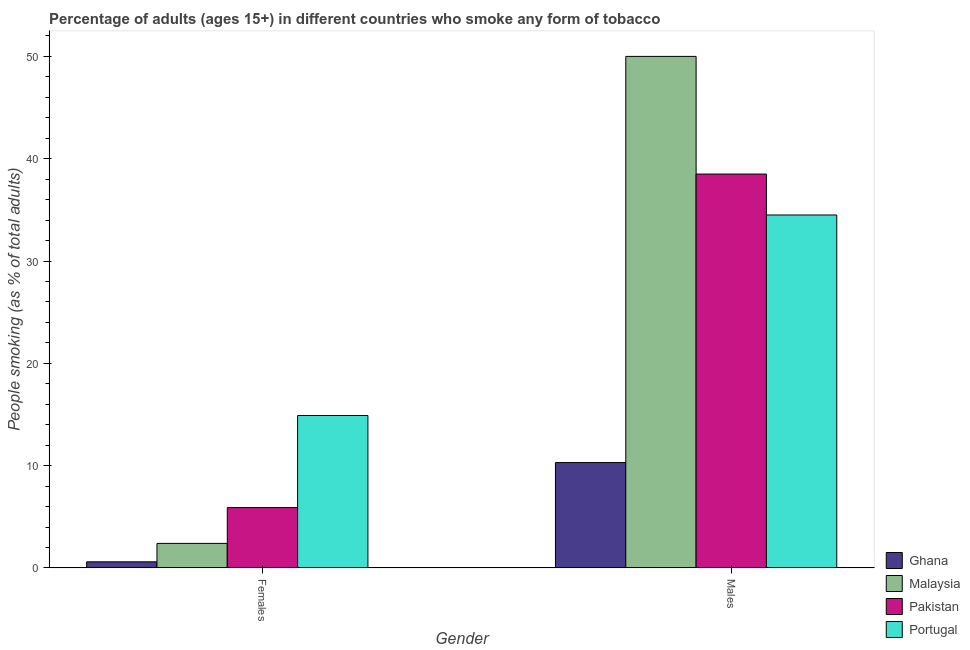Are the number of bars on each tick of the X-axis equal?
Offer a terse response. Yes. How many bars are there on the 2nd tick from the right?
Your response must be concise. 4. What is the label of the 1st group of bars from the left?
Ensure brevity in your answer.  Females. What is the percentage of males who smoke in Portugal?
Your answer should be very brief. 34.5. Across all countries, what is the maximum percentage of males who smoke?
Provide a succinct answer. 50. In which country was the percentage of females who smoke maximum?
Your response must be concise. Portugal. What is the total percentage of males who smoke in the graph?
Offer a terse response. 133.3. What is the difference between the percentage of females who smoke in Portugal and that in Ghana?
Your response must be concise. 14.3. What is the difference between the percentage of females who smoke in Portugal and the percentage of males who smoke in Pakistan?
Offer a very short reply. -23.6. What is the average percentage of males who smoke per country?
Your answer should be compact. 33.33. What is the difference between the percentage of males who smoke and percentage of females who smoke in Portugal?
Your response must be concise. 19.6. In how many countries, is the percentage of females who smoke greater than 12 %?
Keep it short and to the point. 1. What is the ratio of the percentage of females who smoke in Portugal to that in Pakistan?
Your answer should be compact. 2.53. In how many countries, is the percentage of males who smoke greater than the average percentage of males who smoke taken over all countries?
Give a very brief answer. 3. What does the 1st bar from the left in Females represents?
Your answer should be compact. Ghana. What does the 1st bar from the right in Females represents?
Your response must be concise. Portugal. Are all the bars in the graph horizontal?
Your answer should be very brief. No. How many countries are there in the graph?
Offer a very short reply. 4. Are the values on the major ticks of Y-axis written in scientific E-notation?
Offer a terse response. No. Does the graph contain any zero values?
Provide a short and direct response. No. Where does the legend appear in the graph?
Provide a short and direct response. Bottom right. How many legend labels are there?
Provide a succinct answer. 4. How are the legend labels stacked?
Your response must be concise. Vertical. What is the title of the graph?
Ensure brevity in your answer.  Percentage of adults (ages 15+) in different countries who smoke any form of tobacco. What is the label or title of the Y-axis?
Provide a short and direct response. People smoking (as % of total adults). What is the People smoking (as % of total adults) in Malaysia in Females?
Offer a terse response. 2.4. What is the People smoking (as % of total adults) of Portugal in Females?
Your answer should be very brief. 14.9. What is the People smoking (as % of total adults) in Pakistan in Males?
Make the answer very short. 38.5. What is the People smoking (as % of total adults) of Portugal in Males?
Provide a short and direct response. 34.5. Across all Gender, what is the maximum People smoking (as % of total adults) in Ghana?
Your answer should be very brief. 10.3. Across all Gender, what is the maximum People smoking (as % of total adults) in Malaysia?
Your response must be concise. 50. Across all Gender, what is the maximum People smoking (as % of total adults) in Pakistan?
Provide a short and direct response. 38.5. Across all Gender, what is the maximum People smoking (as % of total adults) of Portugal?
Give a very brief answer. 34.5. Across all Gender, what is the minimum People smoking (as % of total adults) in Malaysia?
Offer a very short reply. 2.4. Across all Gender, what is the minimum People smoking (as % of total adults) of Portugal?
Offer a terse response. 14.9. What is the total People smoking (as % of total adults) in Ghana in the graph?
Give a very brief answer. 10.9. What is the total People smoking (as % of total adults) of Malaysia in the graph?
Provide a succinct answer. 52.4. What is the total People smoking (as % of total adults) in Pakistan in the graph?
Give a very brief answer. 44.4. What is the total People smoking (as % of total adults) of Portugal in the graph?
Your answer should be compact. 49.4. What is the difference between the People smoking (as % of total adults) of Malaysia in Females and that in Males?
Make the answer very short. -47.6. What is the difference between the People smoking (as % of total adults) of Pakistan in Females and that in Males?
Keep it short and to the point. -32.6. What is the difference between the People smoking (as % of total adults) of Portugal in Females and that in Males?
Make the answer very short. -19.6. What is the difference between the People smoking (as % of total adults) in Ghana in Females and the People smoking (as % of total adults) in Malaysia in Males?
Offer a terse response. -49.4. What is the difference between the People smoking (as % of total adults) in Ghana in Females and the People smoking (as % of total adults) in Pakistan in Males?
Offer a very short reply. -37.9. What is the difference between the People smoking (as % of total adults) of Ghana in Females and the People smoking (as % of total adults) of Portugal in Males?
Ensure brevity in your answer.  -33.9. What is the difference between the People smoking (as % of total adults) in Malaysia in Females and the People smoking (as % of total adults) in Pakistan in Males?
Provide a short and direct response. -36.1. What is the difference between the People smoking (as % of total adults) of Malaysia in Females and the People smoking (as % of total adults) of Portugal in Males?
Your answer should be very brief. -32.1. What is the difference between the People smoking (as % of total adults) in Pakistan in Females and the People smoking (as % of total adults) in Portugal in Males?
Provide a short and direct response. -28.6. What is the average People smoking (as % of total adults) in Ghana per Gender?
Keep it short and to the point. 5.45. What is the average People smoking (as % of total adults) in Malaysia per Gender?
Your answer should be compact. 26.2. What is the average People smoking (as % of total adults) in Portugal per Gender?
Keep it short and to the point. 24.7. What is the difference between the People smoking (as % of total adults) of Ghana and People smoking (as % of total adults) of Pakistan in Females?
Your response must be concise. -5.3. What is the difference between the People smoking (as % of total adults) in Ghana and People smoking (as % of total adults) in Portugal in Females?
Make the answer very short. -14.3. What is the difference between the People smoking (as % of total adults) in Malaysia and People smoking (as % of total adults) in Pakistan in Females?
Keep it short and to the point. -3.5. What is the difference between the People smoking (as % of total adults) in Ghana and People smoking (as % of total adults) in Malaysia in Males?
Ensure brevity in your answer.  -39.7. What is the difference between the People smoking (as % of total adults) of Ghana and People smoking (as % of total adults) of Pakistan in Males?
Your answer should be compact. -28.2. What is the difference between the People smoking (as % of total adults) of Ghana and People smoking (as % of total adults) of Portugal in Males?
Your answer should be compact. -24.2. What is the difference between the People smoking (as % of total adults) in Malaysia and People smoking (as % of total adults) in Pakistan in Males?
Offer a very short reply. 11.5. What is the ratio of the People smoking (as % of total adults) in Ghana in Females to that in Males?
Your answer should be compact. 0.06. What is the ratio of the People smoking (as % of total adults) in Malaysia in Females to that in Males?
Offer a terse response. 0.05. What is the ratio of the People smoking (as % of total adults) of Pakistan in Females to that in Males?
Your response must be concise. 0.15. What is the ratio of the People smoking (as % of total adults) in Portugal in Females to that in Males?
Make the answer very short. 0.43. What is the difference between the highest and the second highest People smoking (as % of total adults) of Ghana?
Give a very brief answer. 9.7. What is the difference between the highest and the second highest People smoking (as % of total adults) in Malaysia?
Ensure brevity in your answer.  47.6. What is the difference between the highest and the second highest People smoking (as % of total adults) of Pakistan?
Give a very brief answer. 32.6. What is the difference between the highest and the second highest People smoking (as % of total adults) in Portugal?
Provide a succinct answer. 19.6. What is the difference between the highest and the lowest People smoking (as % of total adults) of Malaysia?
Ensure brevity in your answer.  47.6. What is the difference between the highest and the lowest People smoking (as % of total adults) of Pakistan?
Make the answer very short. 32.6. What is the difference between the highest and the lowest People smoking (as % of total adults) of Portugal?
Ensure brevity in your answer.  19.6. 